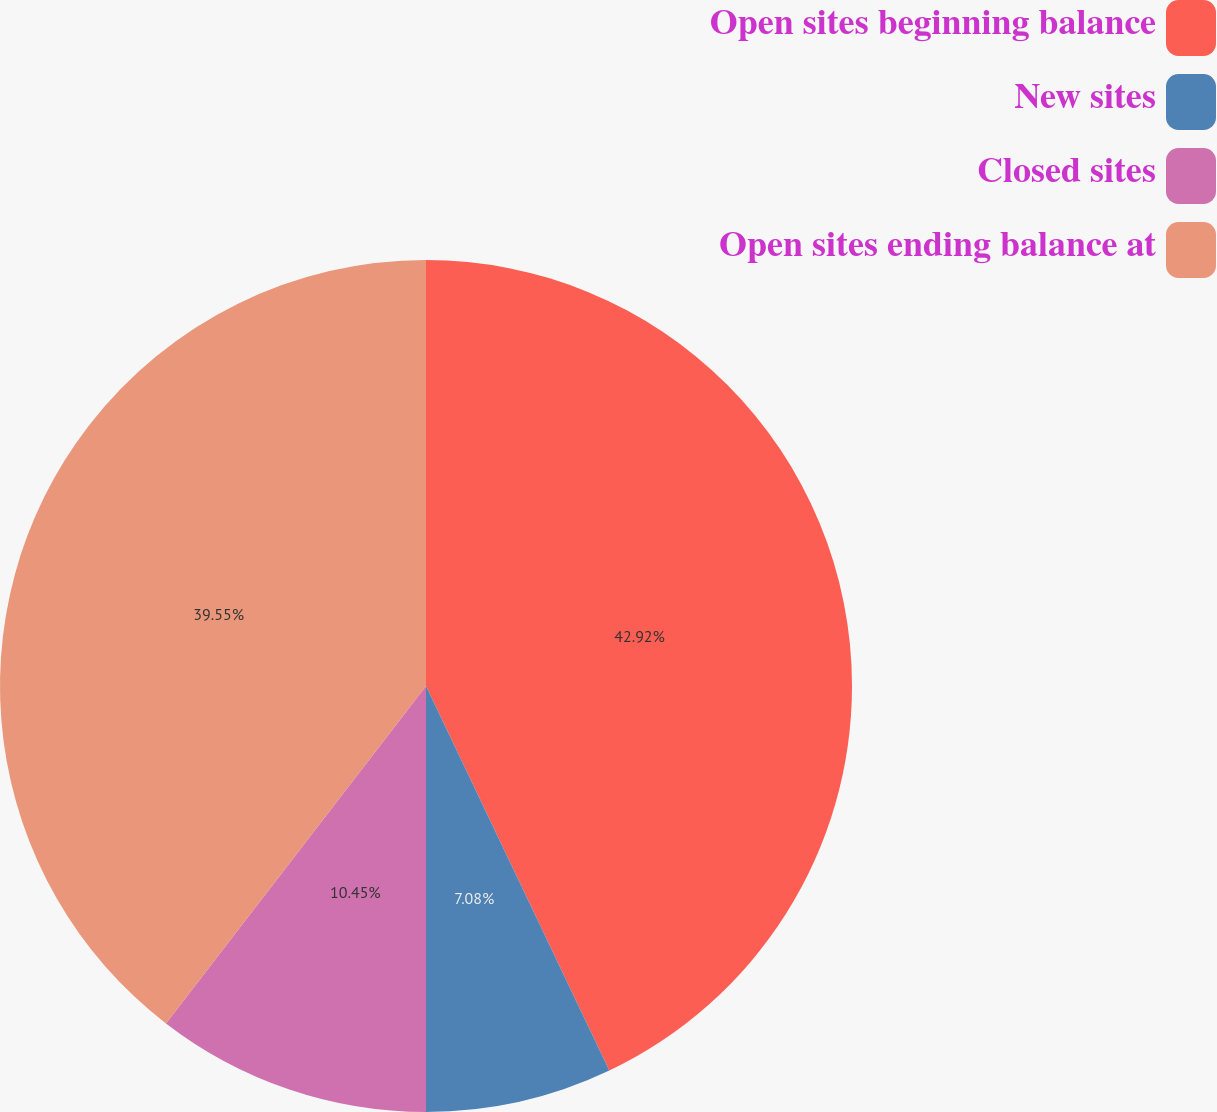Convert chart. <chart><loc_0><loc_0><loc_500><loc_500><pie_chart><fcel>Open sites beginning balance<fcel>New sites<fcel>Closed sites<fcel>Open sites ending balance at<nl><fcel>42.92%<fcel>7.08%<fcel>10.45%<fcel>39.55%<nl></chart> 